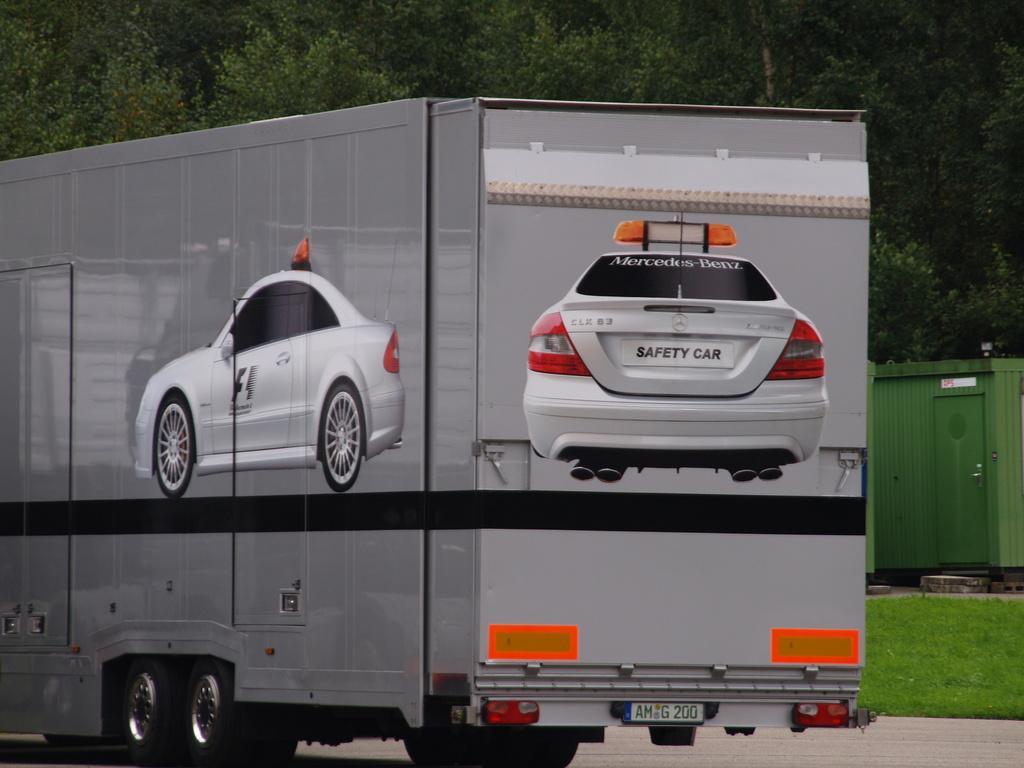Please provide a concise description of this image. In this picture, I can see a few trees and small garden after that i can see a truck and they are two car images which is drawn on truck and finally i can see a door. 